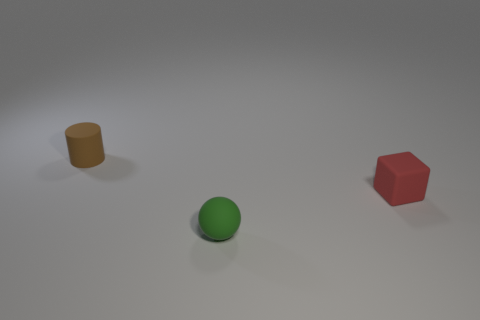Add 1 purple matte cubes. How many purple matte cubes exist? 1 Add 1 small rubber things. How many objects exist? 4 Subtract 0 yellow spheres. How many objects are left? 3 Subtract all cubes. How many objects are left? 2 Subtract all brown cubes. Subtract all gray spheres. How many cubes are left? 1 Subtract all small matte blocks. Subtract all rubber cubes. How many objects are left? 1 Add 3 tiny objects. How many tiny objects are left? 6 